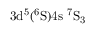Convert formula to latex. <formula><loc_0><loc_0><loc_500><loc_500>3 d ^ { 5 } ( ^ { 6 } S ) 4 s \ ^ { 7 } S _ { 3 }</formula> 